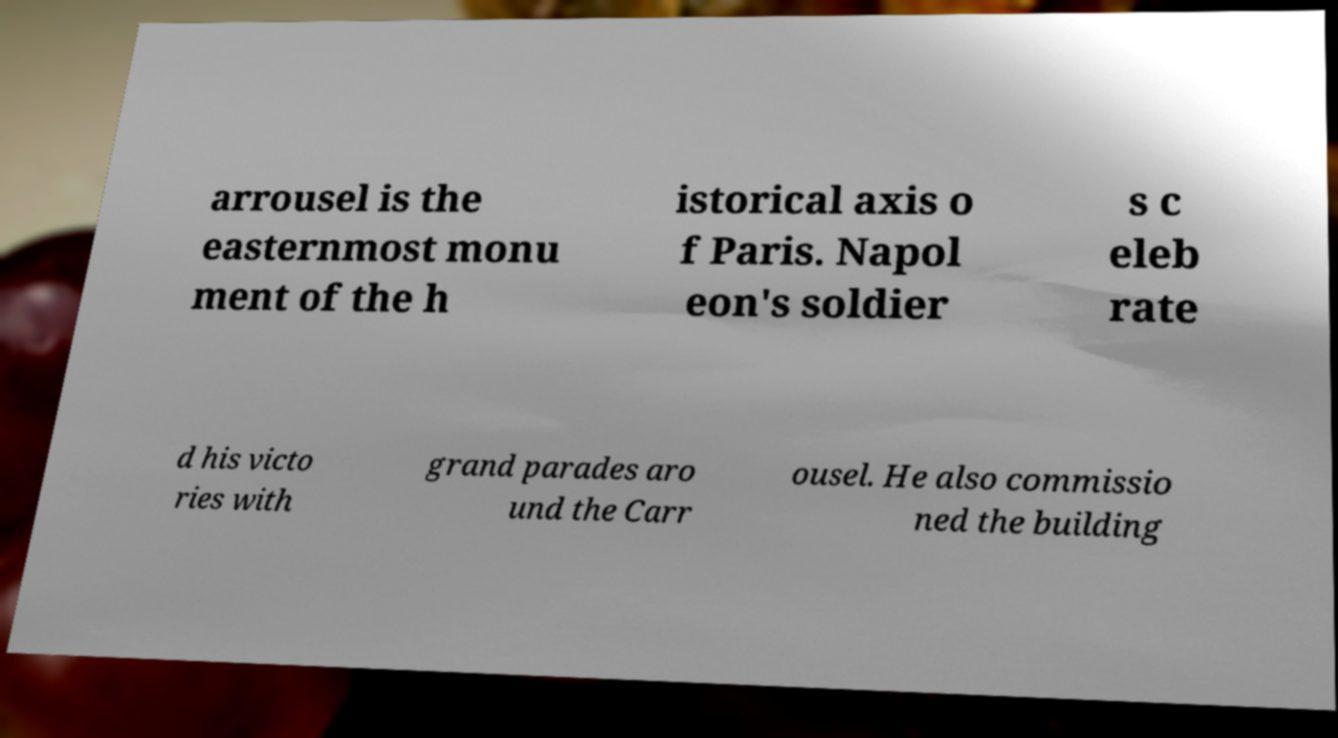Can you read and provide the text displayed in the image?This photo seems to have some interesting text. Can you extract and type it out for me? arrousel is the easternmost monu ment of the h istorical axis o f Paris. Napol eon's soldier s c eleb rate d his victo ries with grand parades aro und the Carr ousel. He also commissio ned the building 